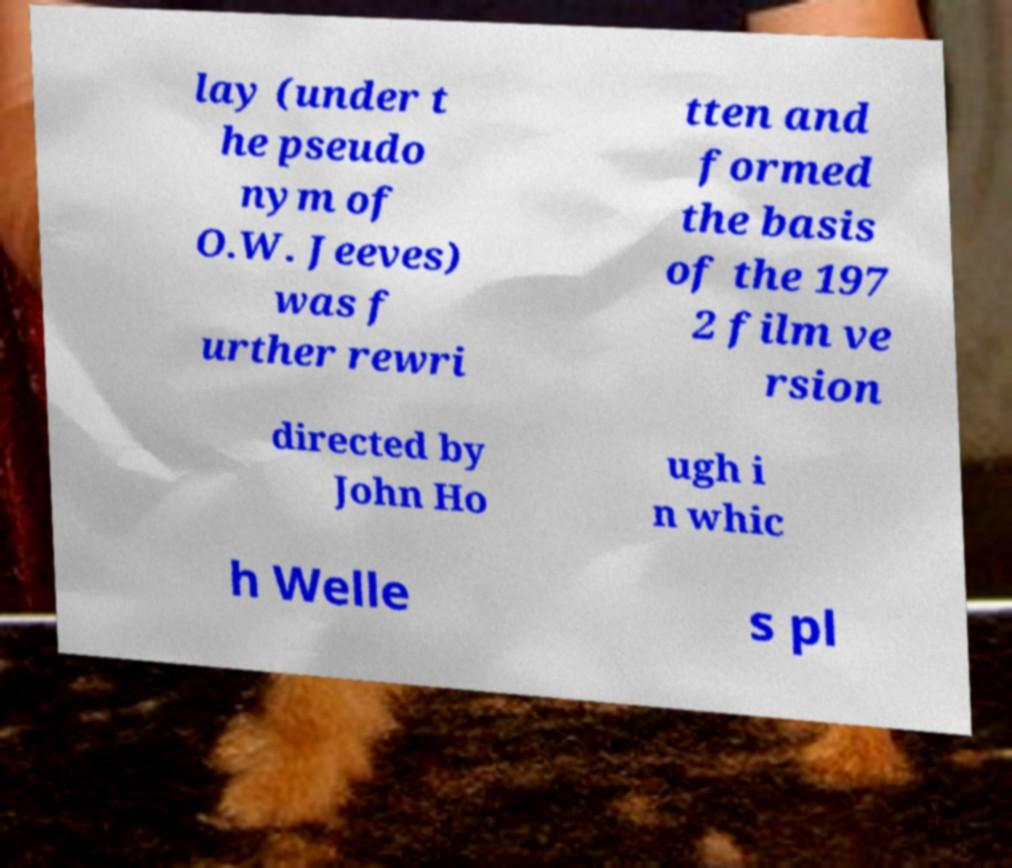Could you assist in decoding the text presented in this image and type it out clearly? lay (under t he pseudo nym of O.W. Jeeves) was f urther rewri tten and formed the basis of the 197 2 film ve rsion directed by John Ho ugh i n whic h Welle s pl 